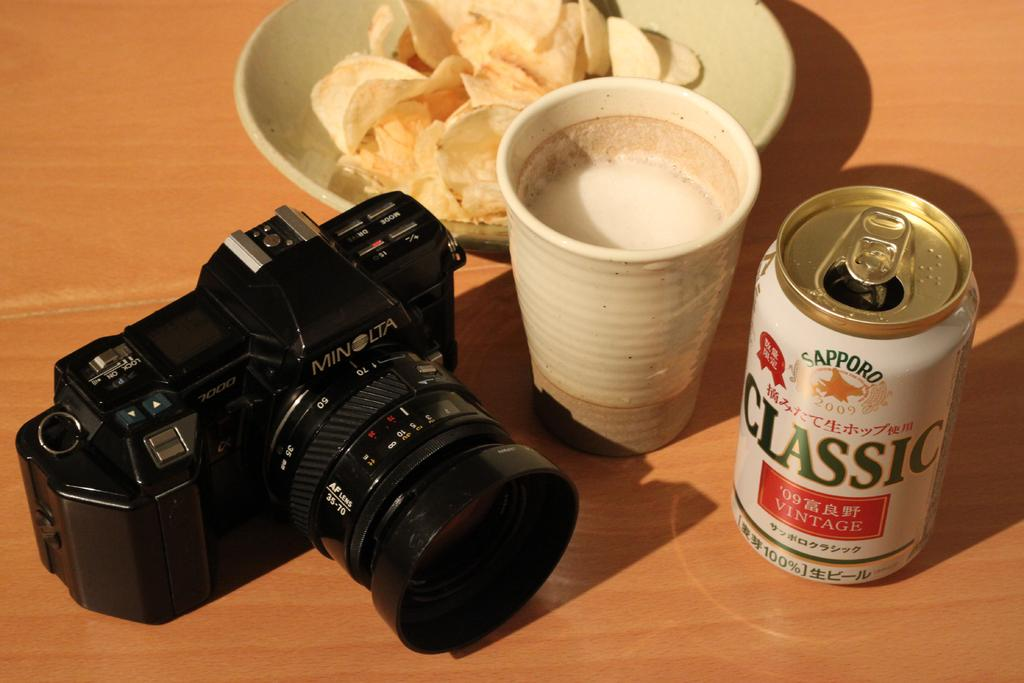What is the main object in the image? There is a camera in the image. What else can be seen on the wooden platform? There is a glass with liquid and a plate with food on the wooden platform. What type of surface is the camera, glass, and plate placed on? The wooden platform is present in the image. What flavor of dinosaur is depicted on the plate in the image? There are no dinosaurs present in the image, and therefore no flavor can be determined. 